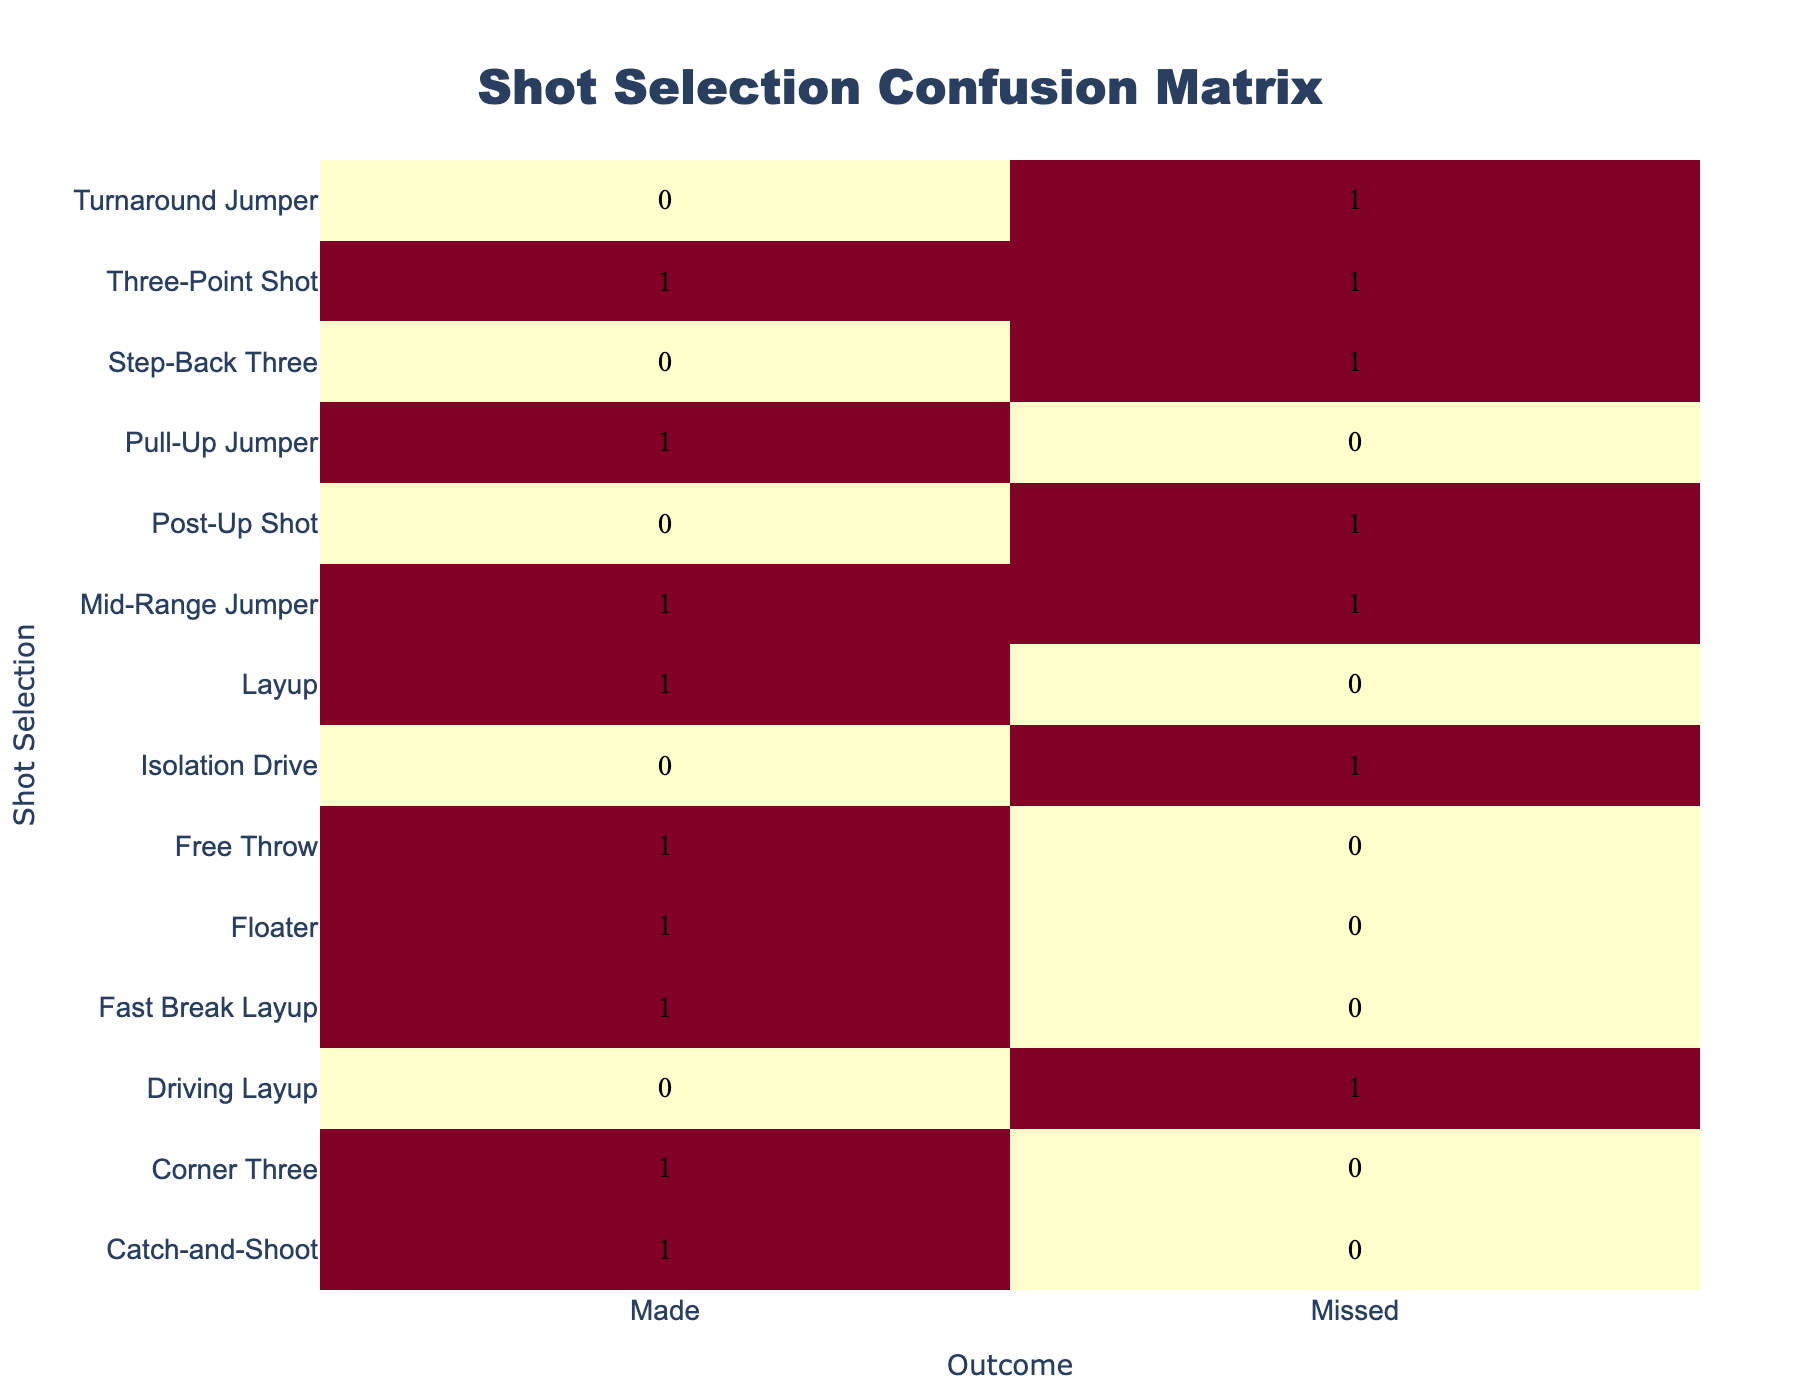What shot selection had the highest number of made baskets? Looking at the table, I find the counts for each shot selection. The "Layup" and "Corner Three" both have counts of 1 for made baskets; however, the "Three-Point Shot" has a total of 2 made baskets. Therefore, "Three-Point Shot" has the highest number of made baskets.
Answer: Three-Point Shot How many shot selections led to missed baskets? The table shows that for each shot selection, some resulted in missed baskets. Scanning the outcomes, I find that there are 8 missed baskets in total across various shot types listed, which is the sum of the missed counts just by looking at the "Missed" column.
Answer: 8 Is it true that most "Mid-Range Jumper" shots were made? Looking at the results for "Mid-Range Jumper" in the table, I see there is one made and one missed shot. Since both counts are equal, the statement is false.
Answer: No What is the total number of made baskets across all shot selections? I need to count the made baskets by checking each row that has "Made" in the outcome. The counts are: 6 made baskets from various shot types (Mid-Range Jumper, Layup, Fast Break Layup, Free Throw, Three-Point Shot, Floater, and Catch-and-Shoot). Summing these gives me a total of 6 made baskets.
Answer: 6 Which shot selection type had the most misses? I can identify the shot types that resulted in missed baskets and their corresponding counts. The "Three-Point Shot" and "Isolation Drive" both have 2 misses, which appears to be the highest among the selections shown. However, there are other selections like "Turnaround Jumper", "Post-Up Shot", and "Driving Layup" each having 1 miss. Hence, "Three-Point Shot" leads in the count for misses.
Answer: Three-Point Shot How many shot types resulted in successful baskets compared to missed? By counting the number of unique shot types in the "Made" column and comparing it to those in the "Missed" column, I see that there are 6 made baskets and 8 missed baskets. Since 6 is less than 8, the statement holds true.
Answer: True 